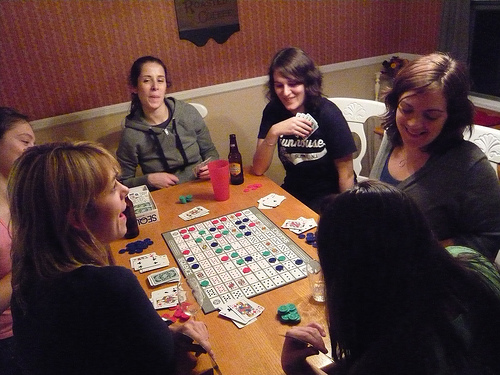<image>
Is there a cards on the game board? Yes. Looking at the image, I can see the cards is positioned on top of the game board, with the game board providing support. Is there a girl behind the girl? Yes. From this viewpoint, the girl is positioned behind the girl, with the girl partially or fully occluding the girl. 